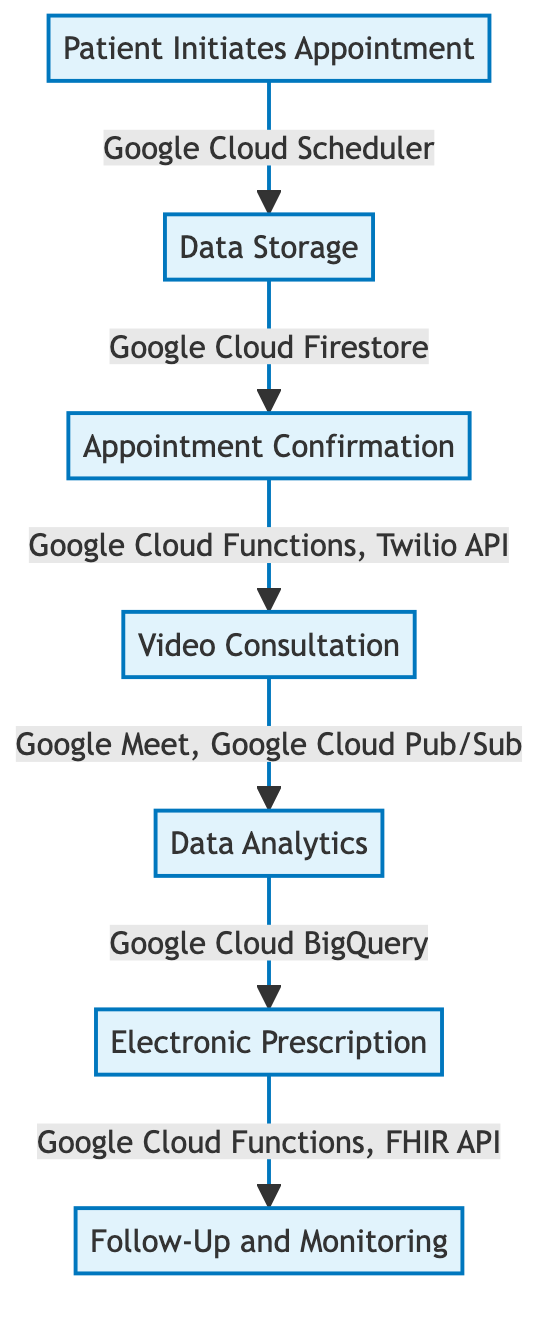What is the first step in the telemedicine workflow? The diagram shows "Patient Initiates Appointment" as the starting node in the workflow, indicating it is the first action taken by the user.
Answer: Patient Initiates Appointment How many components are in the telemedicine workflow? By counting the nodes listed in the diagram, we see there are seven distinct components in the workflow.
Answer: 7 Which service is used for data storage? The diagram indicates that "Data Storage" uses "Google Cloud Firestore" for securely storing patient health records and appointment details.
Answer: Google Cloud Firestore What follows after the video consultation? According to the flow direction shown in the diagram, the next component after "Video Consultation" is "Data Analytics."
Answer: Data Analytics Which services are involved in appointment confirmation? The diagram specifies "Google Cloud Functions" and "Twilio API" as the services used to send appointment confirmations and links.
Answer: Google Cloud Functions, Twilio API What is the purpose of "Data Analytics"? The description in the diagram states that "Data Analytics" involves analyzing patient data for treatment insights and recommendations, highlighting its purpose in the workflow.
Answer: Analysis of patient data for treatment insights and recommendations What component directly links "Electronic Prescription" and "Follow-Up and Monitoring"? The pathway in the diagram shows that "Electronic Prescription" leads directly to "Follow-Up and Monitoring," suggesting a flow from one to the other.
Answer: Follow-Up and Monitoring In which step is the patient's condition monitored? The diagram states that "Follow-Up and Monitoring" is the step where the patient’s condition is remotely monitored following consultation.
Answer: Follow-Up and Monitoring 